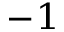<formula> <loc_0><loc_0><loc_500><loc_500>^ { - 1 }</formula> 